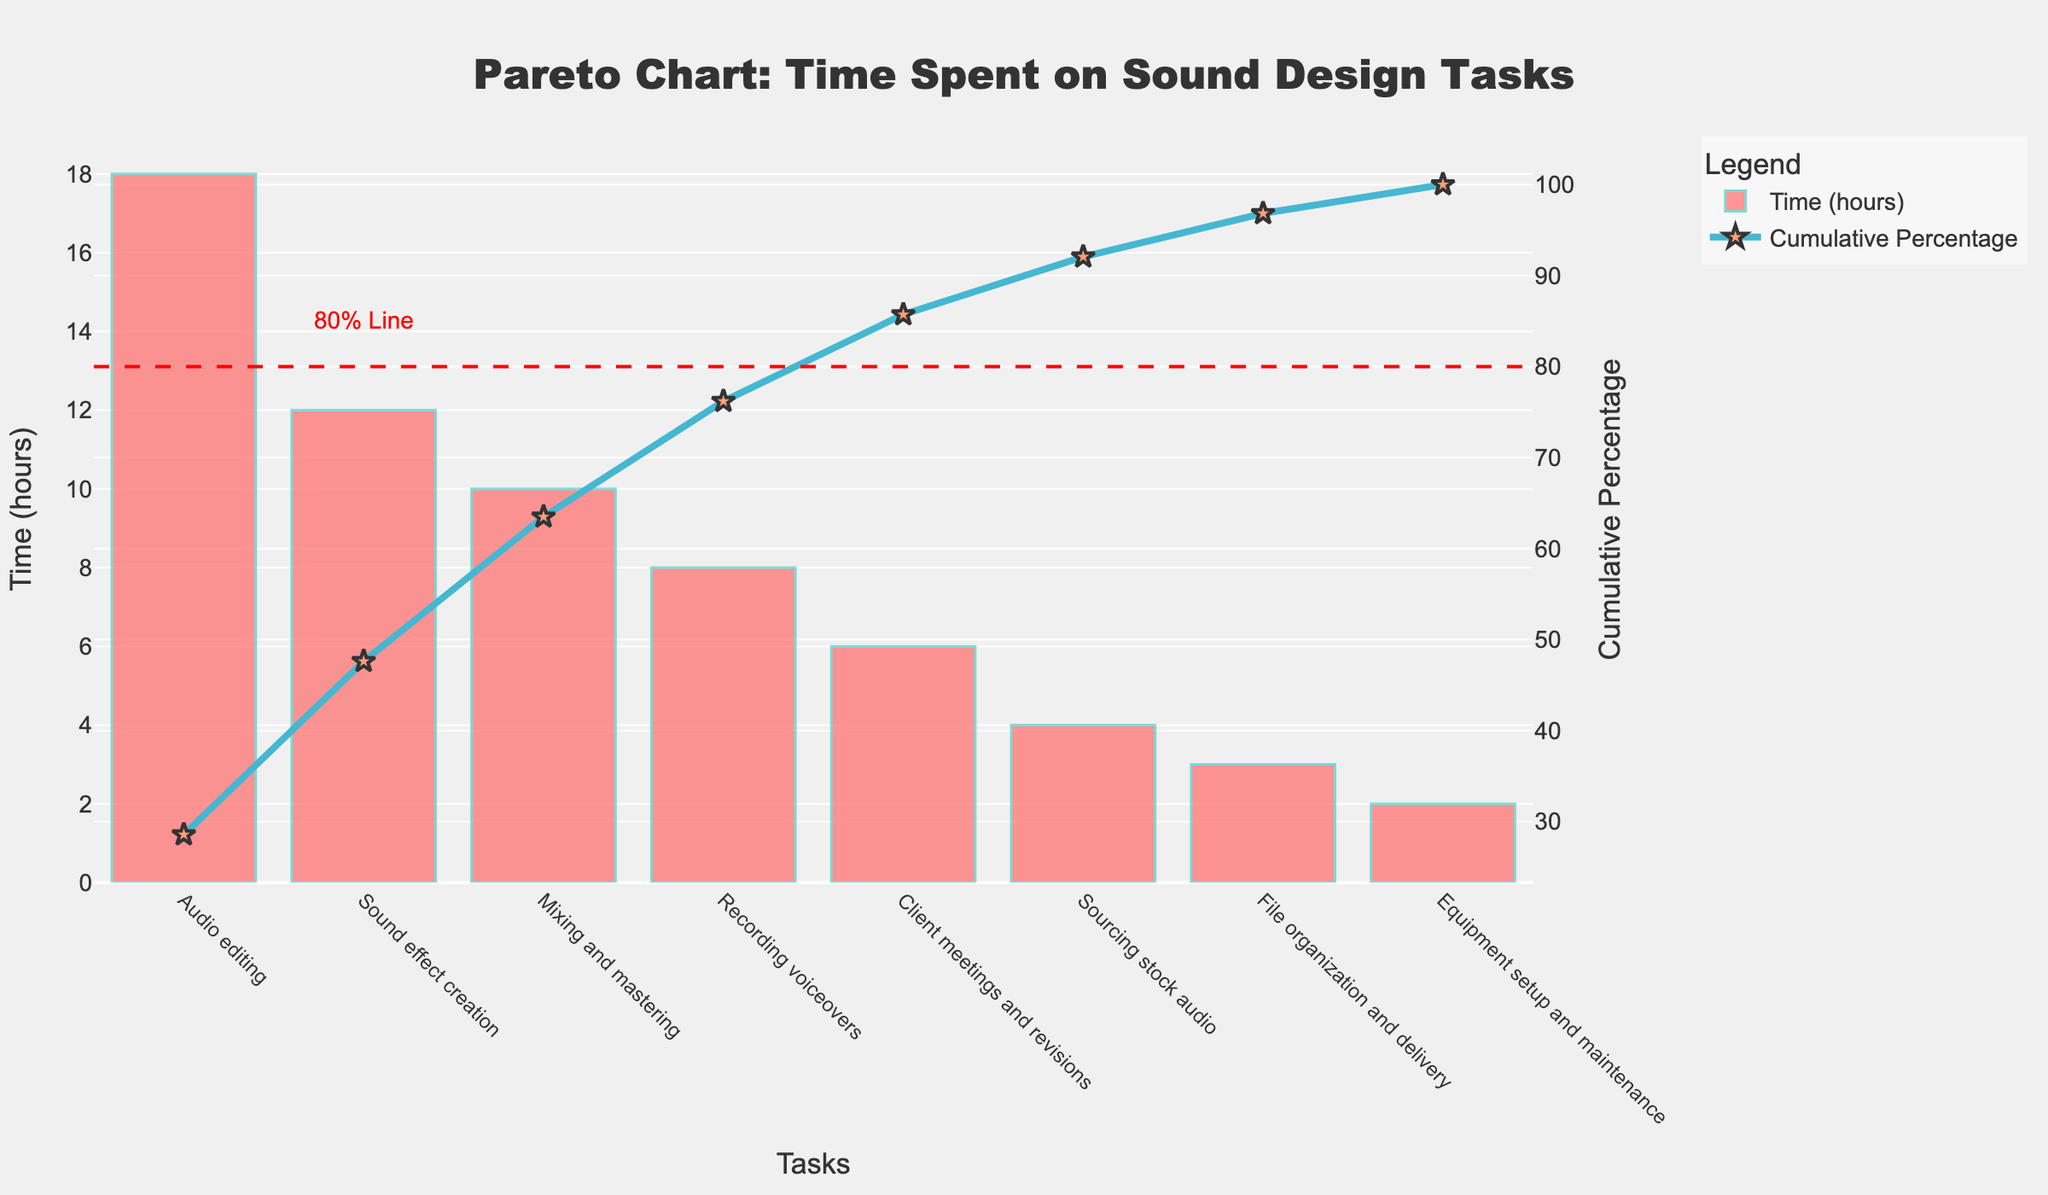What is the title of the chart? The title is prominently displayed at the top-center of the figure. It reads "Pareto Chart: Time Spent on Sound Design Tasks".
Answer: Pareto Chart: Time Spent on Sound Design Tasks Which task takes the most time? The tallest bar represents the task that takes the most time. The bar for "Audio editing" is the tallest.
Answer: Audio editing What is the cumulative percentage of time spent after adding Sourcing stock audio? To find this, sum the cumulative percentages of tasks up to "Sourcing stock audio". The cumulative percentage listed for "Sourcing stock audio" is at about 83%.
Answer: 83% By how many hours does the time spent on Audio editing exceed the time spent on Recording voiceovers? To find the difference, subtract the time for Recording voiceovers (8 hours) from the time for Audio editing (18 hours). 18 - 8 = 10
Answer: 10 What is the total time spent on the three least time-consuming tasks? Add the time spent on File organization and delivery (3 hours), Equipment setup and maintenance (2 hours), and Sourcing stock audio (4 hours). 3 + 2 + 4 = 9
Answer: 9 How many tasks take up to 80% of the total time spent? The 80% cumulative percentage line intersects with the cumulative percentage curve after six tasks.
Answer: 6 Which task is immediately before Mixing and mastering in terms of time spent? According to the descending order of time spent, the task before "Mixing and mastering" is "Sound effect creation".
Answer: Sound effect creation What is the total time spent on tasks that take up 80% of the cumulative percentage? The tasks up to and including "Client meetings and revisions" make up the tasks contributing to 80%. The total time is the sum of these tasks: 18 + 12 + 10 + 8 + 6 = 54
Answer: 54 Which tasks have a cumulative percentage above 50%? Tasks whose cumulative percentages exceed 50% are "Recording voiceovers", "Client meetings and revisions", "Sourcing stock audio", "File organization and delivery", and "Equipment setup and maintenance"
Answer: Recording voiceovers, Client meetings and revisions, Sourcing stock audio, File organization and delivery, Equipment setup and maintenance What color is used to represent the cumulative percentage line? The cumulative percentage line is represented by a blue color.
Answer: Blue 